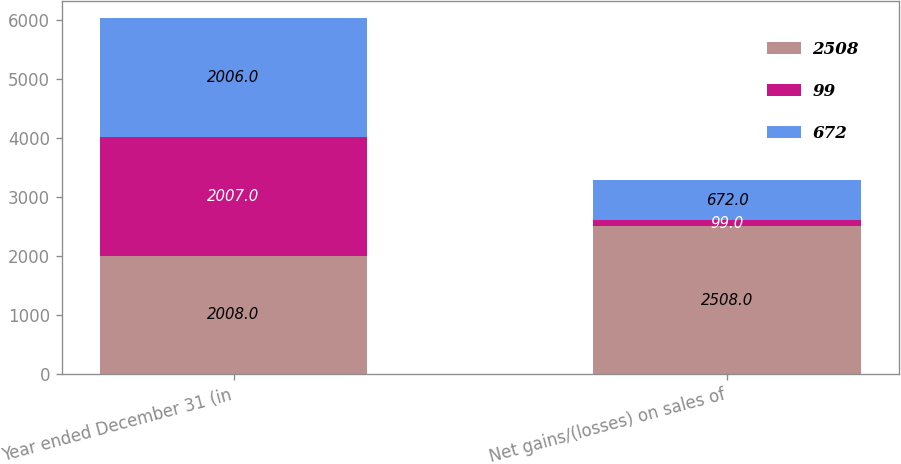<chart> <loc_0><loc_0><loc_500><loc_500><stacked_bar_chart><ecel><fcel>Year ended December 31 (in<fcel>Net gains/(losses) on sales of<nl><fcel>2508<fcel>2008<fcel>2508<nl><fcel>99<fcel>2007<fcel>99<nl><fcel>672<fcel>2006<fcel>672<nl></chart> 